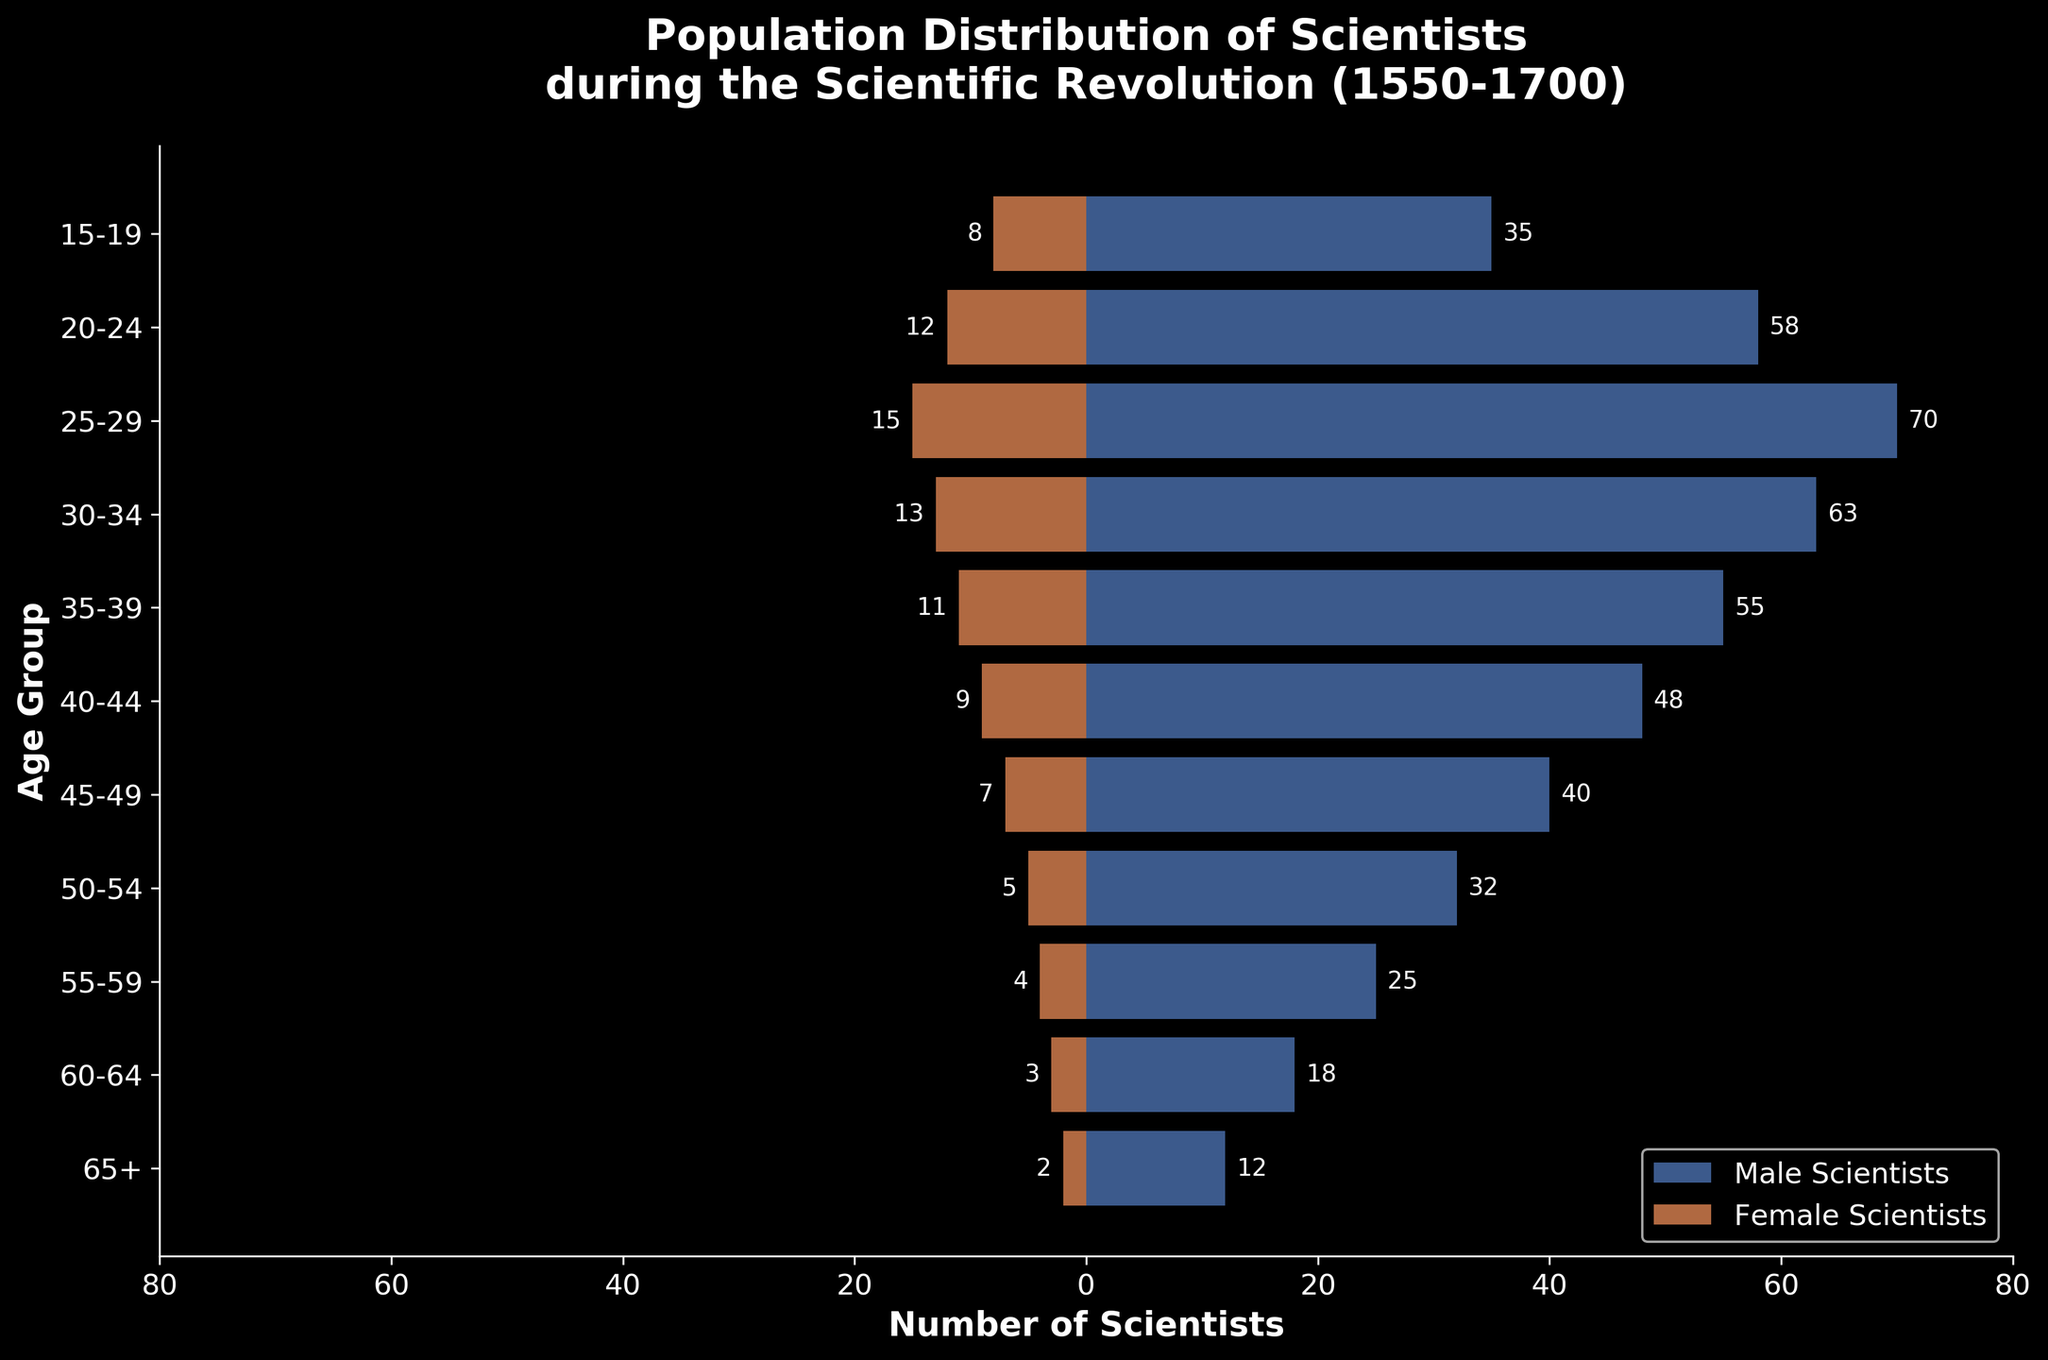What is the age group with the highest number of male scientists? Look at the horizontal bars representing male scientists. The longest bar corresponds to the age group 25-29 with 70 male scientists.
Answer: 25-29 What is the age group with the highest number of female scientists? Look at the horizontal bars representing female scientists. The longest bar corresponds to the age group 25-29 with 15 female scientists.
Answer: 25-29 How many female scientists are there in the 55-59 age group? Locate the 55-59 age group and look at the number next to the bar for female scientists, which is 4.
Answer: 4 How many total scientists are there in the 30-34 age group? Sum the number of male (63) and female (13) scientists in the 30-34 age group. 63 + 13 = 76.
Answer: 76 Which age group has more female scientists: 20-24 or 35-39? Compare the bars for female scientists in the 20-24 (12) and 35-39 (11) age groups. The 20-24 age group has more female scientists.
Answer: 20-24 What is the total number of scientists aged 65+? Add the number of male (12) and female (2) scientists aged 65+. 12 + 2 = 14.
Answer: 14 Is the number of male scientists greater than the number of female scientists in the 45-49 age group? Compare the numbers of male (40) and female (7) scientists in the 45-49 age group. 40 is greater than 7.
Answer: Yes What is the difference in the number of scientists between the 15-19 age group and the 55-59 age group? Calculate the total number of scientists in each age group and find the difference. The 15-19 age group has 35 male and 8 female scientists (43), and the 55-59 age group has 25 male and 4 female scientists (29). Difference: 43 - 29 = 14.
Answer: 14 What is the average number of scientists per age group? Calculate the total number of scientists and divide by the number of age groups (11). Total scientists = 489, so average = 489 / 11 ≈ 44.45.
Answer: 44.45 Which gender has more scientists aged 40-44? Compare the number of male (48) and female (9) scientists in the 40-44 age group. There are more male scientists.
Answer: Male 